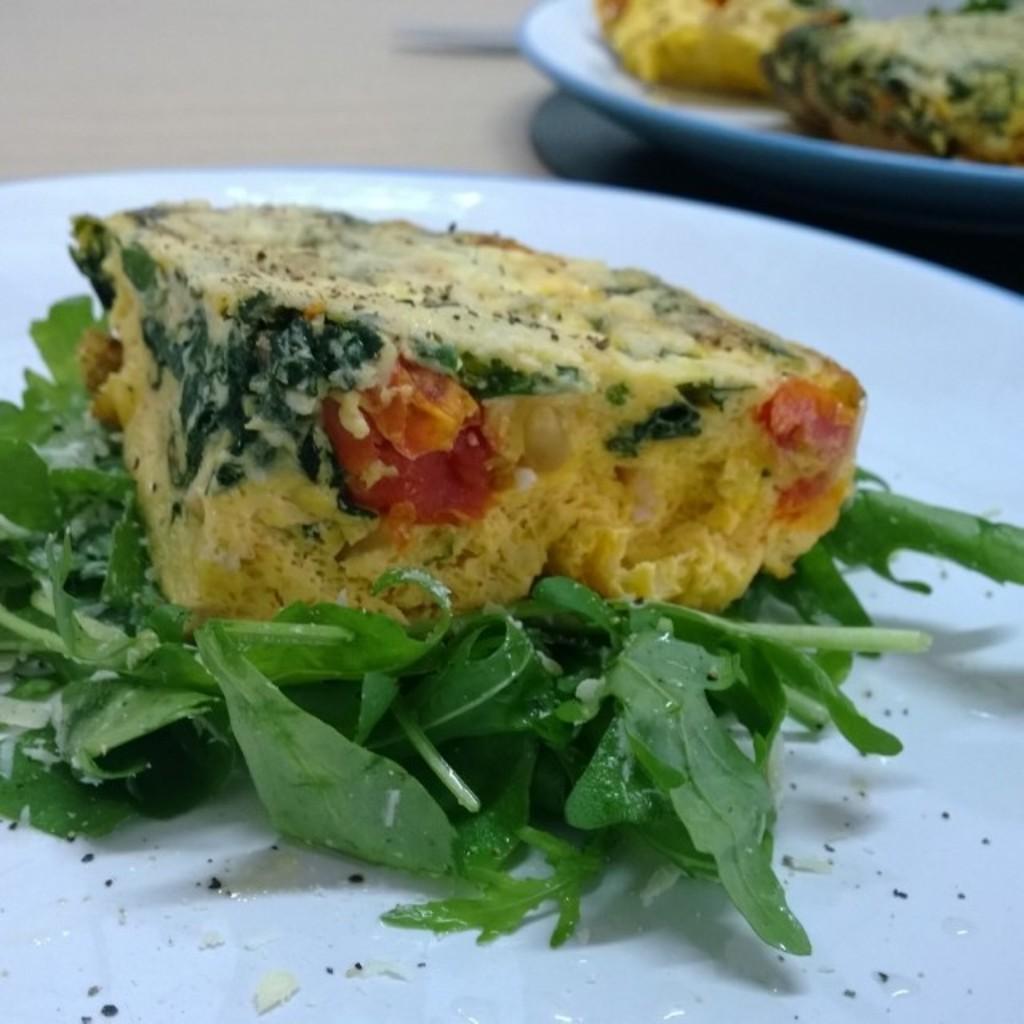Could you give a brief overview of what you see in this image? On this surface there are plates with food. 